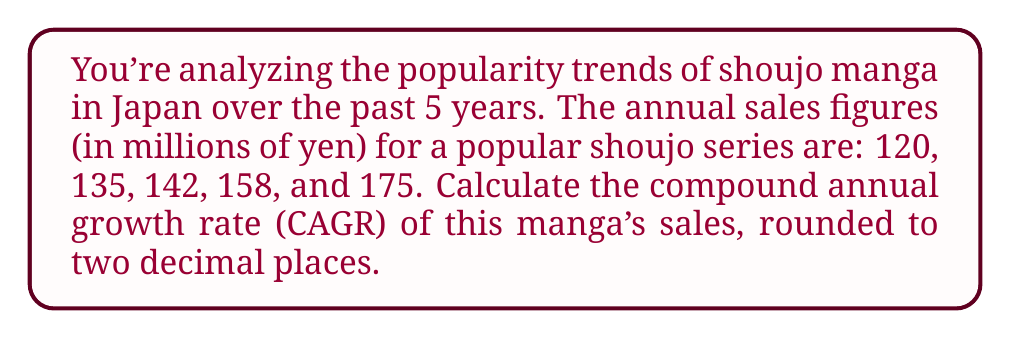Could you help me with this problem? To calculate the Compound Annual Growth Rate (CAGR), we'll use the formula:

$$ CAGR = \left(\frac{Ending Value}{Beginning Value}\right)^{\frac{1}{n}} - 1 $$

Where:
- Ending Value = 175 million yen
- Beginning Value = 120 million yen
- n = 5 years

Step 1: Plug the values into the formula
$$ CAGR = \left(\frac{175}{120}\right)^{\frac{1}{5}} - 1 $$

Step 2: Simplify the fraction inside the parentheses
$$ CAGR = (1.4583333...)^{\frac{1}{5}} - 1 $$

Step 3: Calculate the fifth root
$$ CAGR = 1.0783957... - 1 $$

Step 4: Subtract 1
$$ CAGR = 0.0783957... $$

Step 5: Convert to a percentage and round to two decimal places
$$ CAGR = 7.84\% $$
Answer: 7.84% 